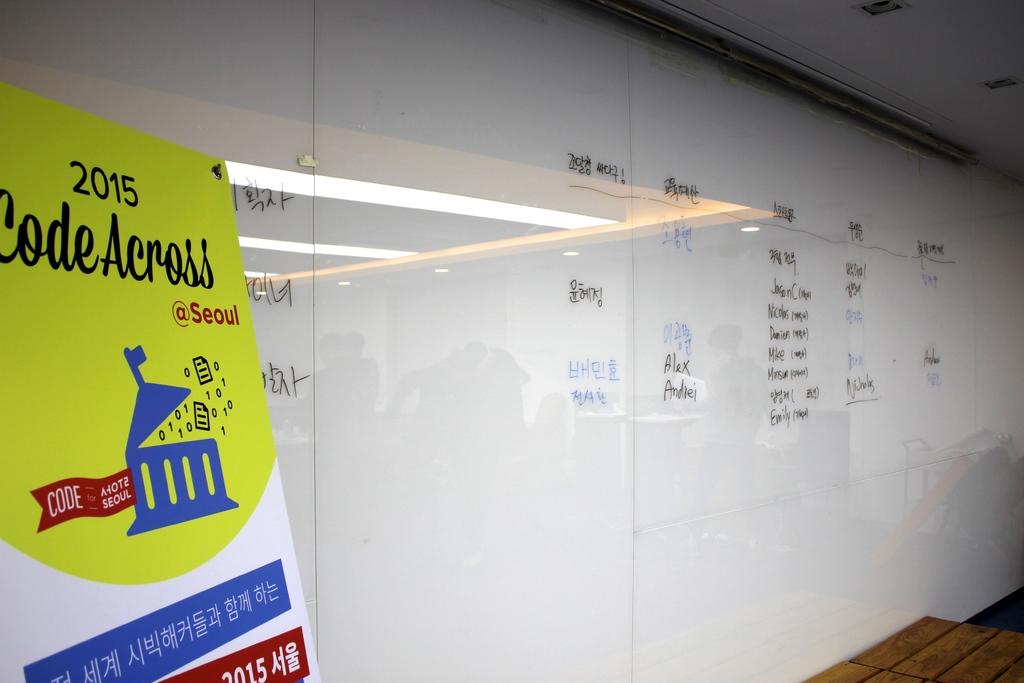Where is this code asses at?
Your answer should be very brief. Seoul. 